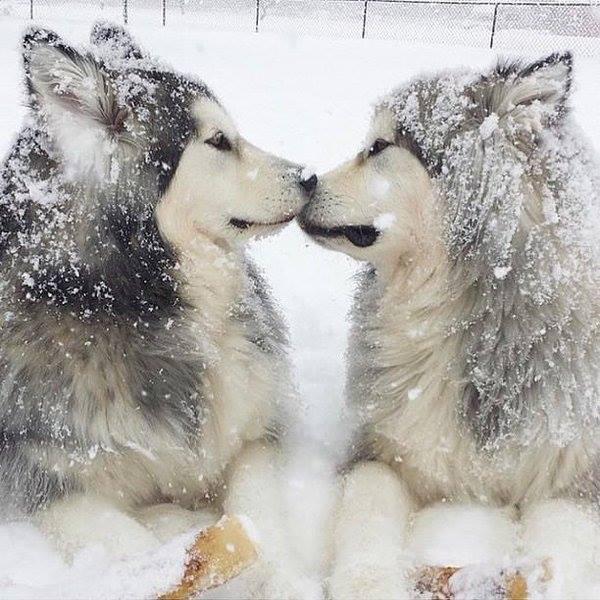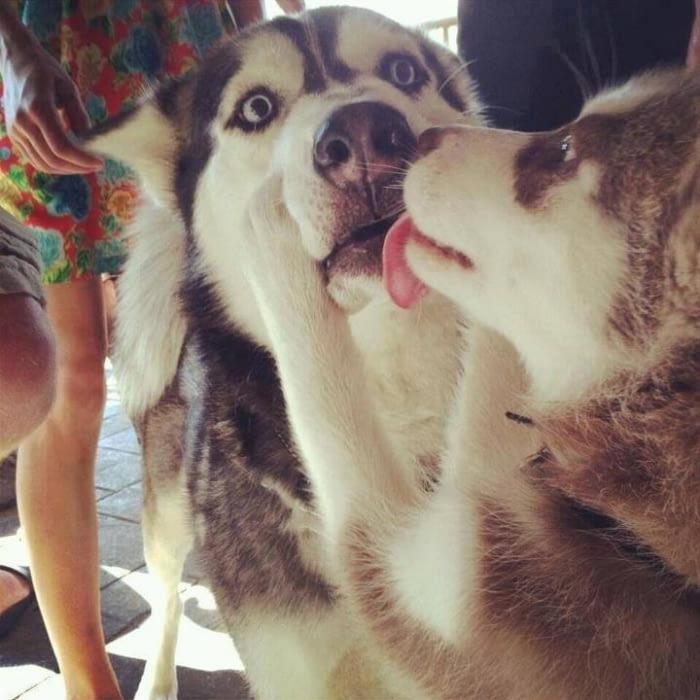The first image is the image on the left, the second image is the image on the right. Analyze the images presented: Is the assertion "The right image includes a dog with its tongue hanging down, and the left image includes a leftward-facing dog with snow on its fur and its paws draped forward." valid? Answer yes or no. Yes. The first image is the image on the left, the second image is the image on the right. Considering the images on both sides, is "The left image has exactly one dog with it's mouth closed, the right image has exactly one dog with it's tongue out." valid? Answer yes or no. No. 